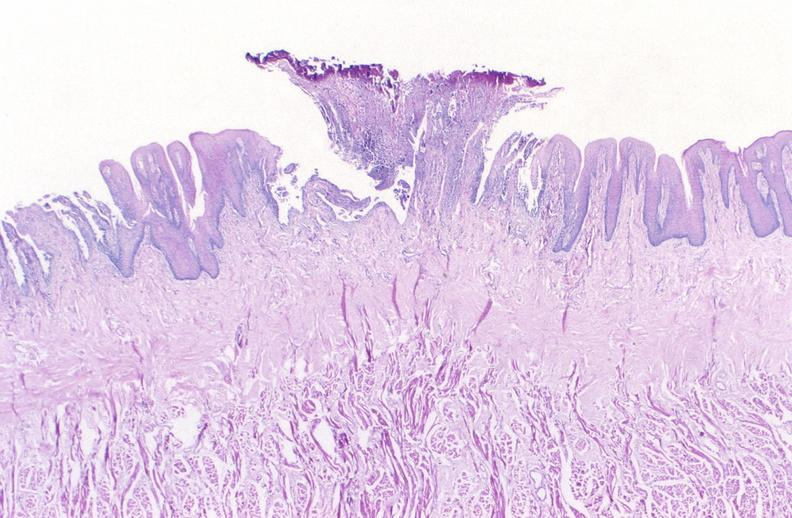does photo show tongue, herpes ulcer?
Answer the question using a single word or phrase. No 